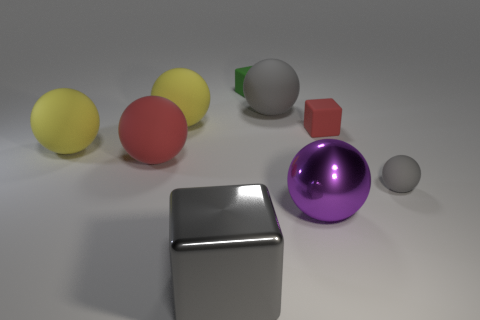Subtract all purple balls. How many balls are left? 5 Subtract all big purple balls. How many balls are left? 5 Subtract 2 spheres. How many spheres are left? 4 Subtract all cyan spheres. Subtract all gray cylinders. How many spheres are left? 6 Subtract all spheres. How many objects are left? 3 Add 3 big gray shiny objects. How many big gray shiny objects are left? 4 Add 6 large gray shiny cubes. How many large gray shiny cubes exist? 7 Subtract 0 yellow cylinders. How many objects are left? 9 Subtract all big red balls. Subtract all gray matte balls. How many objects are left? 6 